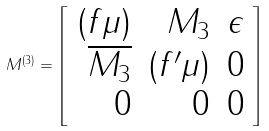Convert formula to latex. <formula><loc_0><loc_0><loc_500><loc_500>M ^ { ( 3 ) } = \left [ \begin{array} { r r r } { ( f \mu ) } & { { M _ { 3 } } } & { \epsilon } \\ { { \overline { { { M _ { 3 } } } } } } & { { ( f ^ { \prime } \mu ) } } & { 0 } \\ { 0 } & { 0 } & { 0 } \end{array} \right ]</formula> 